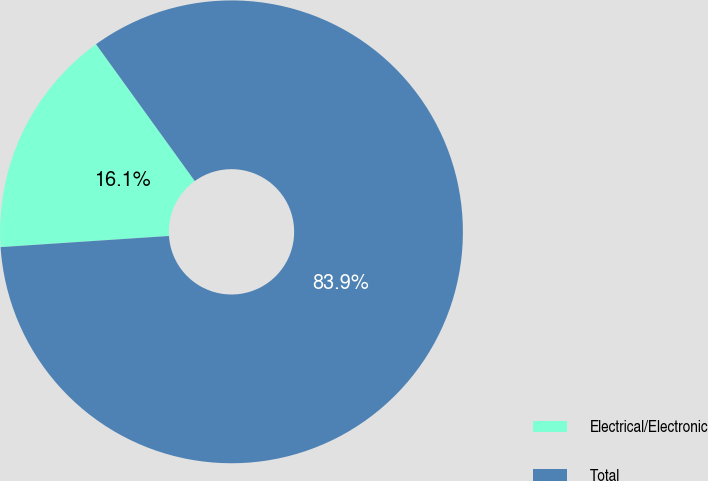Convert chart to OTSL. <chart><loc_0><loc_0><loc_500><loc_500><pie_chart><fcel>Electrical/Electronic<fcel>Total<nl><fcel>16.1%<fcel>83.9%<nl></chart> 